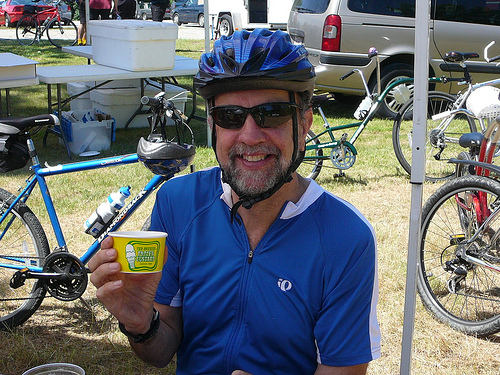What is the man holding in his hand? The man is holding a small tin or packet, possibly a container for a cycling-related product such as energy balm or chamois cream. 